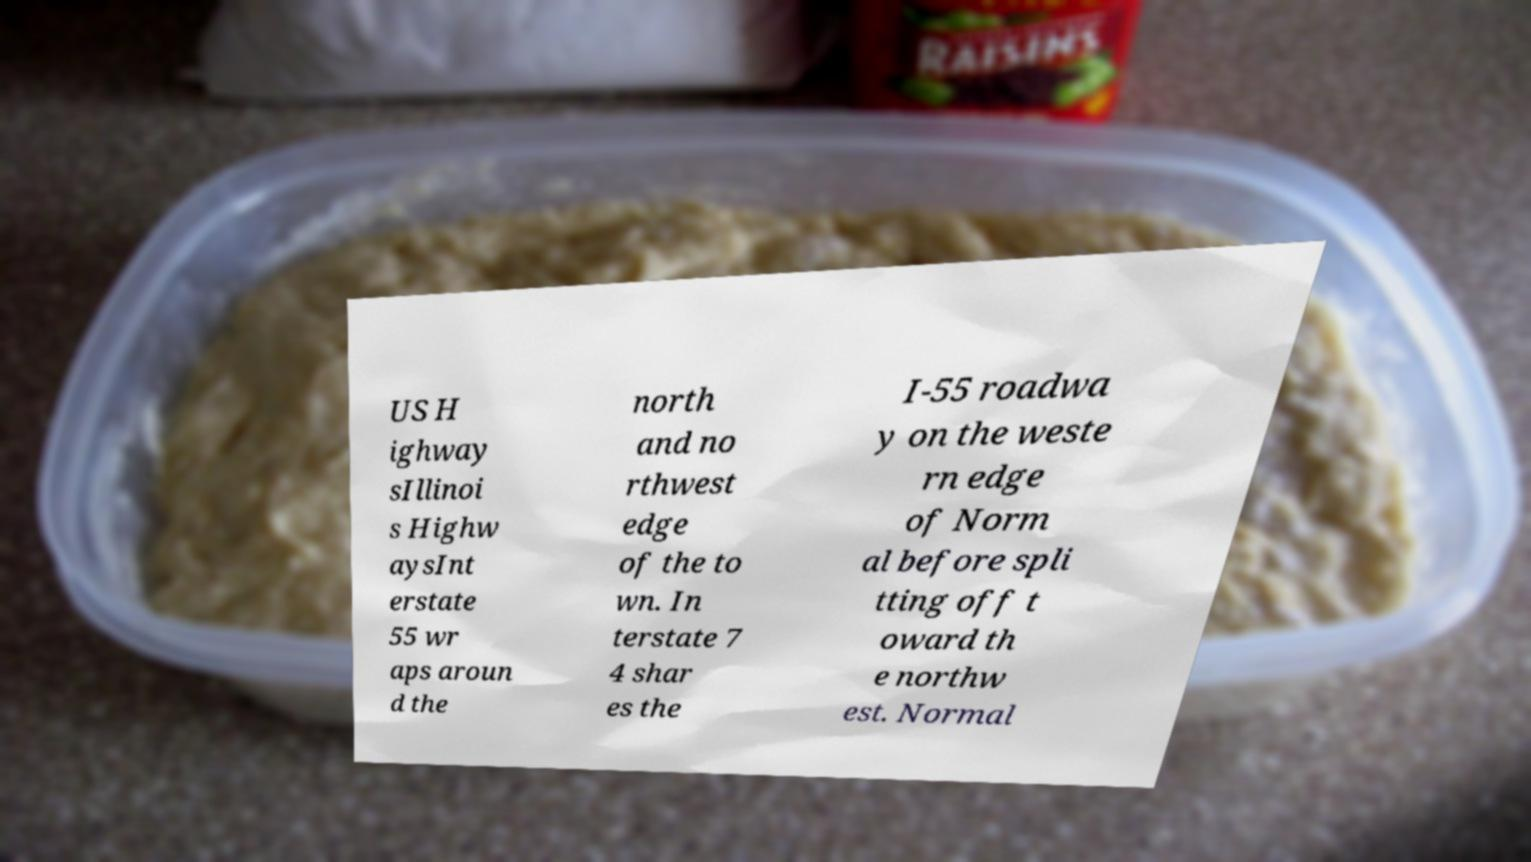What messages or text are displayed in this image? I need them in a readable, typed format. US H ighway sIllinoi s Highw aysInt erstate 55 wr aps aroun d the north and no rthwest edge of the to wn. In terstate 7 4 shar es the I-55 roadwa y on the weste rn edge of Norm al before spli tting off t oward th e northw est. Normal 